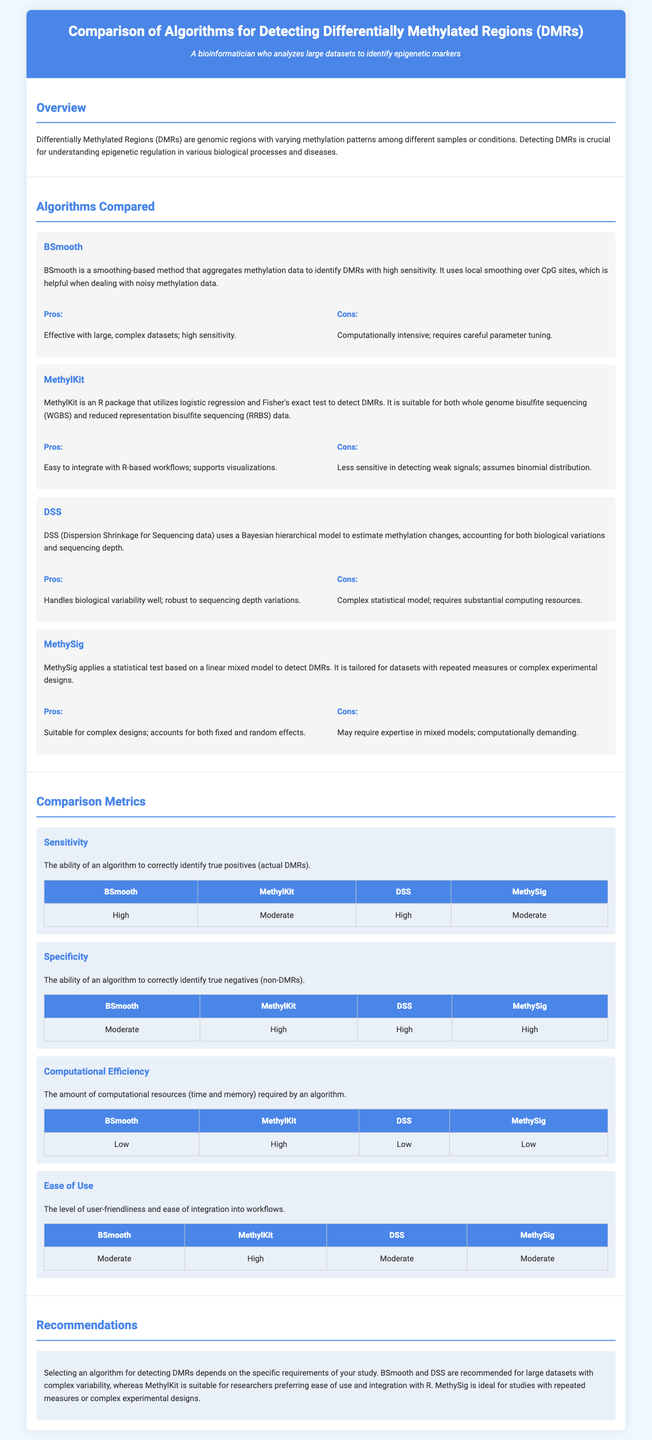What is the primary focus of the infographic? The primary focus is on comparing algorithms for detecting differentially methylated regions (DMRs).
Answer: Detecting differentially methylated regions (DMRs) Which algorithm is known for its high sensitivity? BSmooth and DSS both have high sensitivity according to the comparison metrics.
Answer: BSmooth, DSS What does MethylKit primarily utilize to detect DMRs? MethylKit uses logistic regression and Fisher's exact test for detecting DMRs.
Answer: Logistic regression and Fisher's exact test What is a key advantage of using DSS? DSS handles biological variability well, making it a robust option for analysis.
Answer: Handles biological variability Which algorithm has a high ease of use rating? MethylKit has a high ease of use rating as per the comparison metrics.
Answer: MethylKit What is the computational efficiency rating for MethylKit? MethylKit is rated high in terms of computational efficiency.
Answer: High Which algorithm is recommended for studies with repeated measures? MethySig is identified as ideal for studies with repeated measures or complex experimental designs.
Answer: MethySig What is the general recommendation for large datasets? BSmooth and DSS are recommended for large datasets with complex variability.
Answer: BSmooth and DSS What is the specificity rating for BSmooth? The specificity rating for BSmooth is moderate according to the table.
Answer: Moderate 